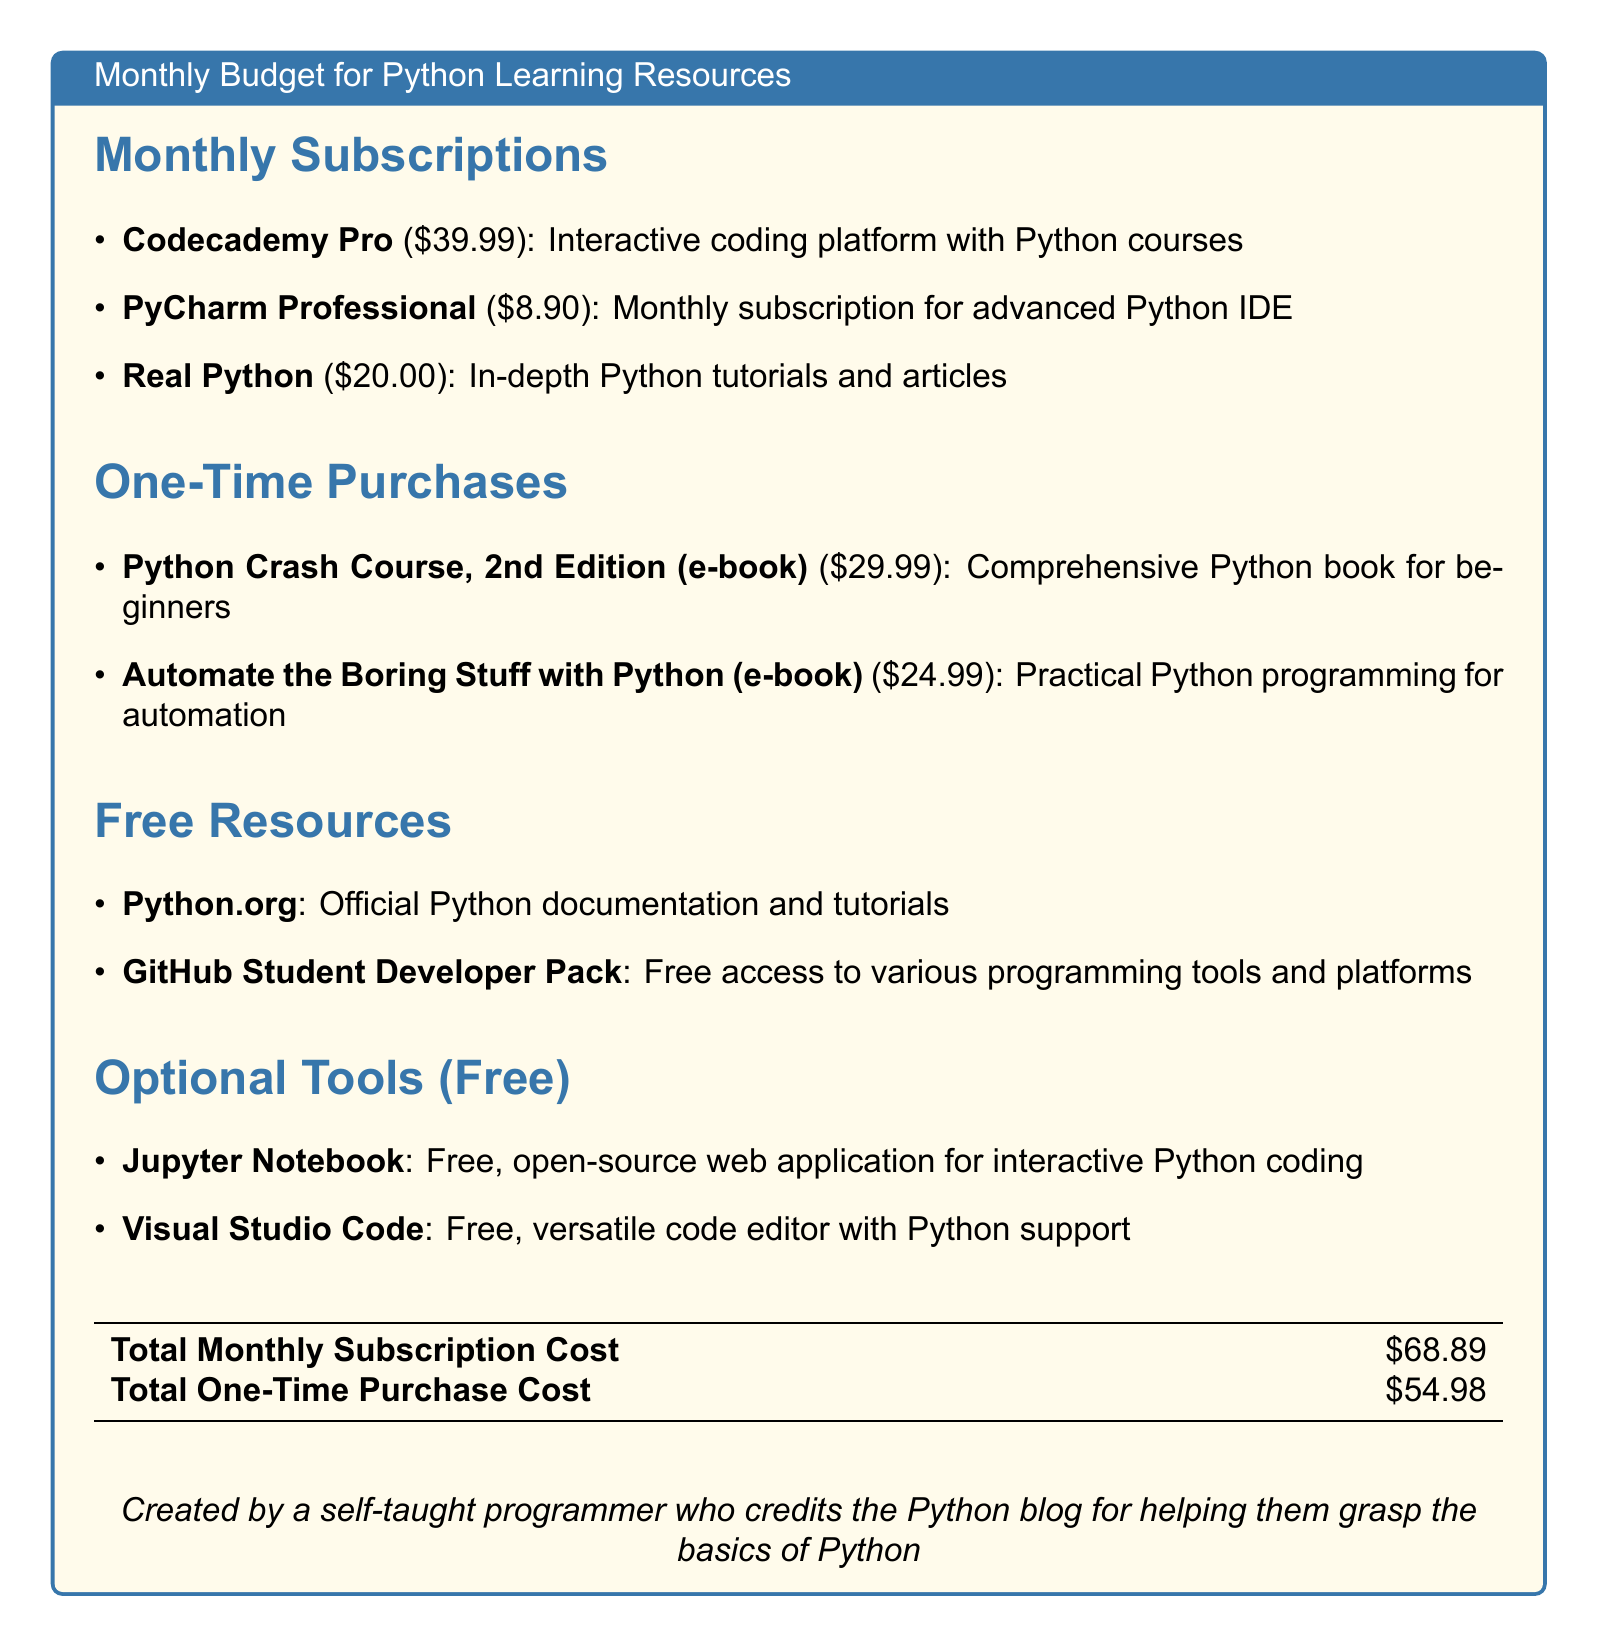What is the total monthly subscription cost? The total monthly subscription cost is presented in the document, which sums up the amounts of the monthly subscriptions, resulting in $68.89.
Answer: $68.89 How many one-time purchases are listed? The document contains a section on one-time purchases. There are two items mentioned under that section.
Answer: 2 What is the cost of Codecademy Pro? Codecademy Pro is listed with a specific cost in the subscriptions section of the document, which is $39.99.
Answer: $39.99 Name one free resource mentioned. The document lists free resources in a separate section. One of them is Python.org.
Answer: Python.org What is the price of the e-book "Automate the Boring Stuff with Python"? The e-book price for "Automate the Boring Stuff with Python" is explicitly stated in the one-time purchases section, which is $24.99.
Answer: $24.99 Which tool is recommended for interactive Python coding? The document mentions Jupyter Notebook as an optional tool for interactive Python coding.
Answer: Jupyter Notebook What is the price of PyCharm Professional? The price for PyCharm Professional is provided in the document, specified as $8.90.
Answer: $8.90 What type of document is this? The structure and content of the document indicate it is a budget for online learning resources and programming tools.
Answer: Budget 